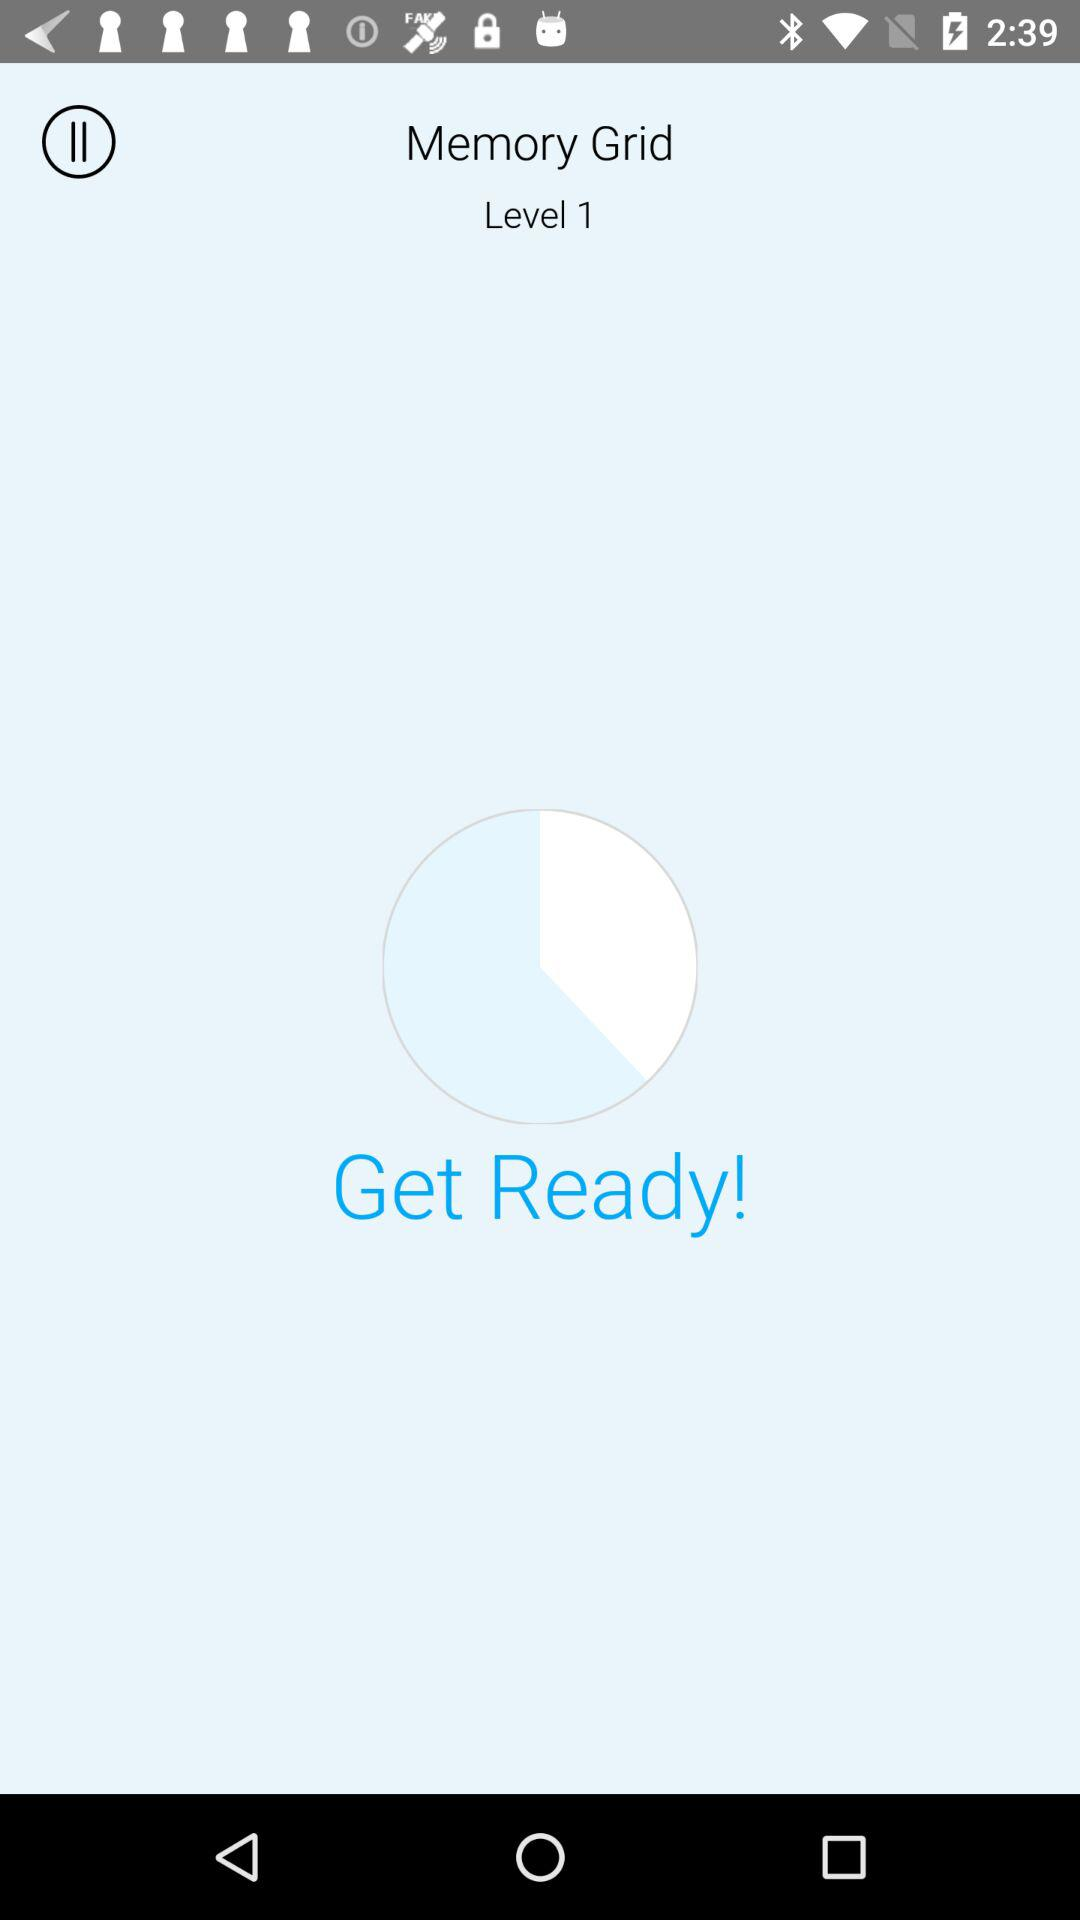What is the name of this level? The name of this level is "Memory Grid". 